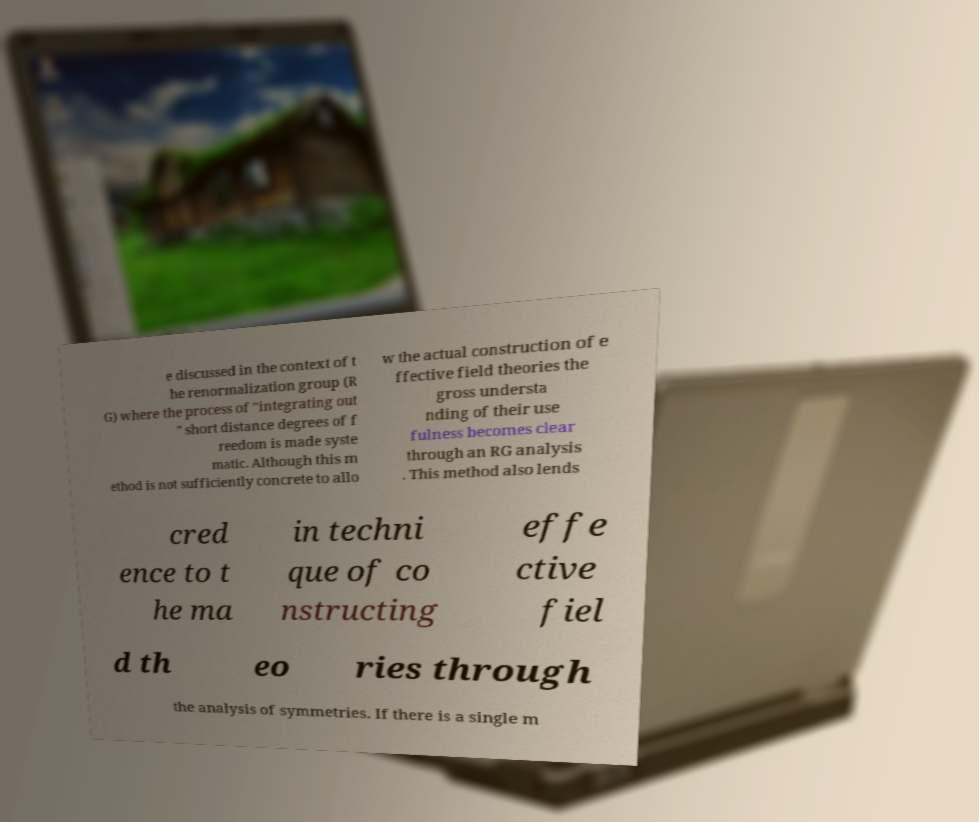Could you extract and type out the text from this image? e discussed in the context of t he renormalization group (R G) where the process of "integrating out " short distance degrees of f reedom is made syste matic. Although this m ethod is not sufficiently concrete to allo w the actual construction of e ffective field theories the gross understa nding of their use fulness becomes clear through an RG analysis . This method also lends cred ence to t he ma in techni que of co nstructing effe ctive fiel d th eo ries through the analysis of symmetries. If there is a single m 